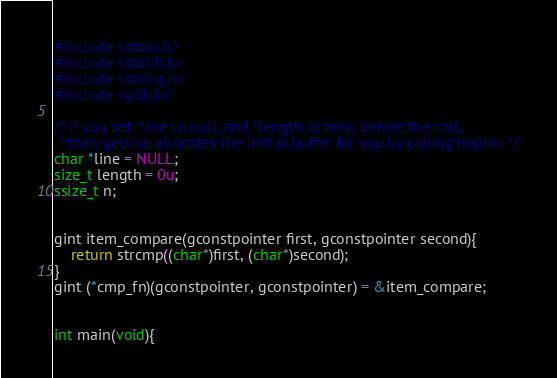<code> <loc_0><loc_0><loc_500><loc_500><_C_>
#include <stdio.h>
#include <stdlib.h>
#include <string.h>
#include <glib.h>

/* If you set *line to null, and *length to zero, before the call,
 * then getline allocates the initial buffer for you by calling malloc */
char *line = NULL;
size_t length = 0u;
ssize_t n;


gint item_compare(gconstpointer first, gconstpointer second){
    return strcmp((char*)first, (char*)second);
}
gint (*cmp_fn)(gconstpointer, gconstpointer) = &item_compare;


int main(void){
</code> 